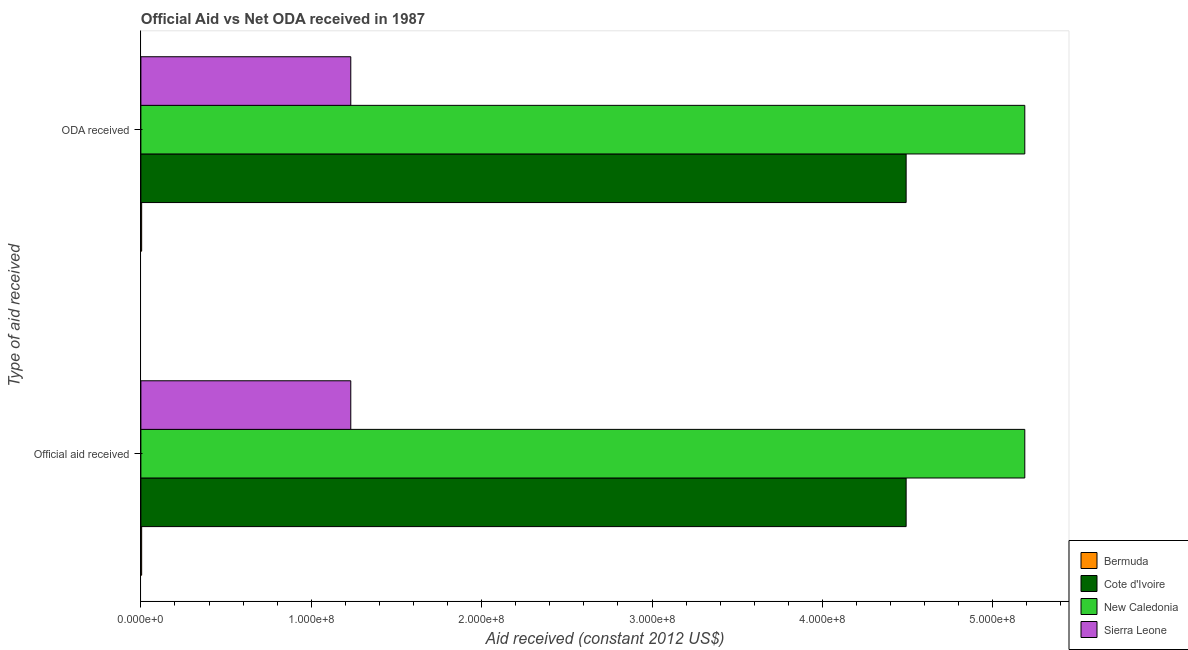How many groups of bars are there?
Give a very brief answer. 2. How many bars are there on the 2nd tick from the top?
Provide a succinct answer. 4. What is the label of the 1st group of bars from the top?
Give a very brief answer. ODA received. What is the oda received in Cote d'Ivoire?
Provide a succinct answer. 4.49e+08. Across all countries, what is the maximum oda received?
Offer a very short reply. 5.19e+08. Across all countries, what is the minimum oda received?
Provide a succinct answer. 4.50e+05. In which country was the official aid received maximum?
Give a very brief answer. New Caledonia. In which country was the oda received minimum?
Ensure brevity in your answer.  Bermuda. What is the total oda received in the graph?
Provide a succinct answer. 1.09e+09. What is the difference between the official aid received in Cote d'Ivoire and that in Sierra Leone?
Make the answer very short. 3.26e+08. What is the difference between the official aid received in New Caledonia and the oda received in Sierra Leone?
Offer a terse response. 3.96e+08. What is the average oda received per country?
Ensure brevity in your answer.  2.73e+08. What is the difference between the official aid received and oda received in New Caledonia?
Provide a succinct answer. 0. In how many countries, is the oda received greater than 40000000 US$?
Offer a very short reply. 3. What is the ratio of the oda received in Cote d'Ivoire to that in Sierra Leone?
Your answer should be very brief. 3.65. Is the official aid received in Cote d'Ivoire less than that in New Caledonia?
Provide a short and direct response. Yes. What does the 3rd bar from the top in Official aid received represents?
Offer a terse response. Cote d'Ivoire. What does the 3rd bar from the bottom in Official aid received represents?
Give a very brief answer. New Caledonia. How many bars are there?
Ensure brevity in your answer.  8. Are the values on the major ticks of X-axis written in scientific E-notation?
Your answer should be compact. Yes. Does the graph contain grids?
Your answer should be very brief. No. How are the legend labels stacked?
Make the answer very short. Vertical. What is the title of the graph?
Ensure brevity in your answer.  Official Aid vs Net ODA received in 1987 . What is the label or title of the X-axis?
Ensure brevity in your answer.  Aid received (constant 2012 US$). What is the label or title of the Y-axis?
Offer a terse response. Type of aid received. What is the Aid received (constant 2012 US$) in Bermuda in Official aid received?
Provide a succinct answer. 4.50e+05. What is the Aid received (constant 2012 US$) in Cote d'Ivoire in Official aid received?
Your response must be concise. 4.49e+08. What is the Aid received (constant 2012 US$) in New Caledonia in Official aid received?
Offer a very short reply. 5.19e+08. What is the Aid received (constant 2012 US$) of Sierra Leone in Official aid received?
Keep it short and to the point. 1.23e+08. What is the Aid received (constant 2012 US$) of Cote d'Ivoire in ODA received?
Your response must be concise. 4.49e+08. What is the Aid received (constant 2012 US$) of New Caledonia in ODA received?
Your answer should be compact. 5.19e+08. What is the Aid received (constant 2012 US$) of Sierra Leone in ODA received?
Offer a terse response. 1.23e+08. Across all Type of aid received, what is the maximum Aid received (constant 2012 US$) in Bermuda?
Offer a terse response. 4.50e+05. Across all Type of aid received, what is the maximum Aid received (constant 2012 US$) of Cote d'Ivoire?
Your answer should be very brief. 4.49e+08. Across all Type of aid received, what is the maximum Aid received (constant 2012 US$) of New Caledonia?
Offer a very short reply. 5.19e+08. Across all Type of aid received, what is the maximum Aid received (constant 2012 US$) in Sierra Leone?
Ensure brevity in your answer.  1.23e+08. Across all Type of aid received, what is the minimum Aid received (constant 2012 US$) in Cote d'Ivoire?
Offer a terse response. 4.49e+08. Across all Type of aid received, what is the minimum Aid received (constant 2012 US$) of New Caledonia?
Ensure brevity in your answer.  5.19e+08. Across all Type of aid received, what is the minimum Aid received (constant 2012 US$) of Sierra Leone?
Make the answer very short. 1.23e+08. What is the total Aid received (constant 2012 US$) in Bermuda in the graph?
Offer a terse response. 9.00e+05. What is the total Aid received (constant 2012 US$) of Cote d'Ivoire in the graph?
Make the answer very short. 8.98e+08. What is the total Aid received (constant 2012 US$) of New Caledonia in the graph?
Make the answer very short. 1.04e+09. What is the total Aid received (constant 2012 US$) of Sierra Leone in the graph?
Give a very brief answer. 2.46e+08. What is the difference between the Aid received (constant 2012 US$) in New Caledonia in Official aid received and that in ODA received?
Offer a terse response. 0. What is the difference between the Aid received (constant 2012 US$) in Bermuda in Official aid received and the Aid received (constant 2012 US$) in Cote d'Ivoire in ODA received?
Your answer should be very brief. -4.49e+08. What is the difference between the Aid received (constant 2012 US$) in Bermuda in Official aid received and the Aid received (constant 2012 US$) in New Caledonia in ODA received?
Make the answer very short. -5.18e+08. What is the difference between the Aid received (constant 2012 US$) of Bermuda in Official aid received and the Aid received (constant 2012 US$) of Sierra Leone in ODA received?
Give a very brief answer. -1.23e+08. What is the difference between the Aid received (constant 2012 US$) of Cote d'Ivoire in Official aid received and the Aid received (constant 2012 US$) of New Caledonia in ODA received?
Offer a terse response. -6.96e+07. What is the difference between the Aid received (constant 2012 US$) of Cote d'Ivoire in Official aid received and the Aid received (constant 2012 US$) of Sierra Leone in ODA received?
Your answer should be compact. 3.26e+08. What is the difference between the Aid received (constant 2012 US$) in New Caledonia in Official aid received and the Aid received (constant 2012 US$) in Sierra Leone in ODA received?
Offer a very short reply. 3.96e+08. What is the average Aid received (constant 2012 US$) of Cote d'Ivoire per Type of aid received?
Your answer should be compact. 4.49e+08. What is the average Aid received (constant 2012 US$) in New Caledonia per Type of aid received?
Your response must be concise. 5.19e+08. What is the average Aid received (constant 2012 US$) in Sierra Leone per Type of aid received?
Keep it short and to the point. 1.23e+08. What is the difference between the Aid received (constant 2012 US$) of Bermuda and Aid received (constant 2012 US$) of Cote d'Ivoire in Official aid received?
Offer a terse response. -4.49e+08. What is the difference between the Aid received (constant 2012 US$) of Bermuda and Aid received (constant 2012 US$) of New Caledonia in Official aid received?
Make the answer very short. -5.18e+08. What is the difference between the Aid received (constant 2012 US$) of Bermuda and Aid received (constant 2012 US$) of Sierra Leone in Official aid received?
Your answer should be very brief. -1.23e+08. What is the difference between the Aid received (constant 2012 US$) in Cote d'Ivoire and Aid received (constant 2012 US$) in New Caledonia in Official aid received?
Offer a terse response. -6.96e+07. What is the difference between the Aid received (constant 2012 US$) of Cote d'Ivoire and Aid received (constant 2012 US$) of Sierra Leone in Official aid received?
Provide a short and direct response. 3.26e+08. What is the difference between the Aid received (constant 2012 US$) of New Caledonia and Aid received (constant 2012 US$) of Sierra Leone in Official aid received?
Ensure brevity in your answer.  3.96e+08. What is the difference between the Aid received (constant 2012 US$) in Bermuda and Aid received (constant 2012 US$) in Cote d'Ivoire in ODA received?
Ensure brevity in your answer.  -4.49e+08. What is the difference between the Aid received (constant 2012 US$) of Bermuda and Aid received (constant 2012 US$) of New Caledonia in ODA received?
Your answer should be very brief. -5.18e+08. What is the difference between the Aid received (constant 2012 US$) of Bermuda and Aid received (constant 2012 US$) of Sierra Leone in ODA received?
Offer a very short reply. -1.23e+08. What is the difference between the Aid received (constant 2012 US$) in Cote d'Ivoire and Aid received (constant 2012 US$) in New Caledonia in ODA received?
Provide a succinct answer. -6.96e+07. What is the difference between the Aid received (constant 2012 US$) of Cote d'Ivoire and Aid received (constant 2012 US$) of Sierra Leone in ODA received?
Your answer should be very brief. 3.26e+08. What is the difference between the Aid received (constant 2012 US$) in New Caledonia and Aid received (constant 2012 US$) in Sierra Leone in ODA received?
Your answer should be very brief. 3.96e+08. What is the ratio of the Aid received (constant 2012 US$) in Cote d'Ivoire in Official aid received to that in ODA received?
Offer a terse response. 1. What is the difference between the highest and the second highest Aid received (constant 2012 US$) of Bermuda?
Give a very brief answer. 0. What is the difference between the highest and the second highest Aid received (constant 2012 US$) in Cote d'Ivoire?
Provide a short and direct response. 0. What is the difference between the highest and the second highest Aid received (constant 2012 US$) of New Caledonia?
Offer a very short reply. 0. What is the difference between the highest and the second highest Aid received (constant 2012 US$) of Sierra Leone?
Offer a very short reply. 0. What is the difference between the highest and the lowest Aid received (constant 2012 US$) of New Caledonia?
Give a very brief answer. 0. What is the difference between the highest and the lowest Aid received (constant 2012 US$) in Sierra Leone?
Provide a short and direct response. 0. 